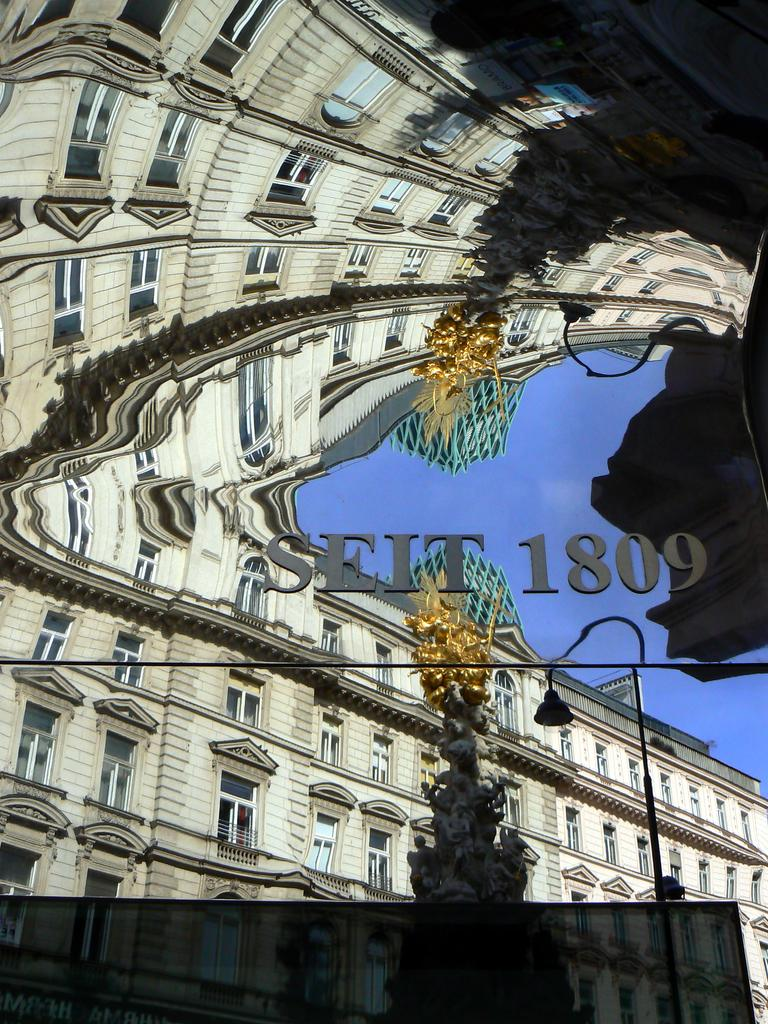What is being reflected in the image? The image contains a reflection of a building, windows, a statue, light, a pole, some text, and the sky. Can you describe the reflection of the windows? Yes, there is a reflection of windows in the image. What is the statue reflecting in the image? The statue is visible in the reflection. What is the source of the light in the reflection? There is a reflection of light in the image. What else is present in the reflection besides the building and windows? A pole, some text, and the sky are also visible in the reflection. What caption is written below the reflection in the image? There is no caption present in the image; it is a reflection of various elements without any accompanying text. 